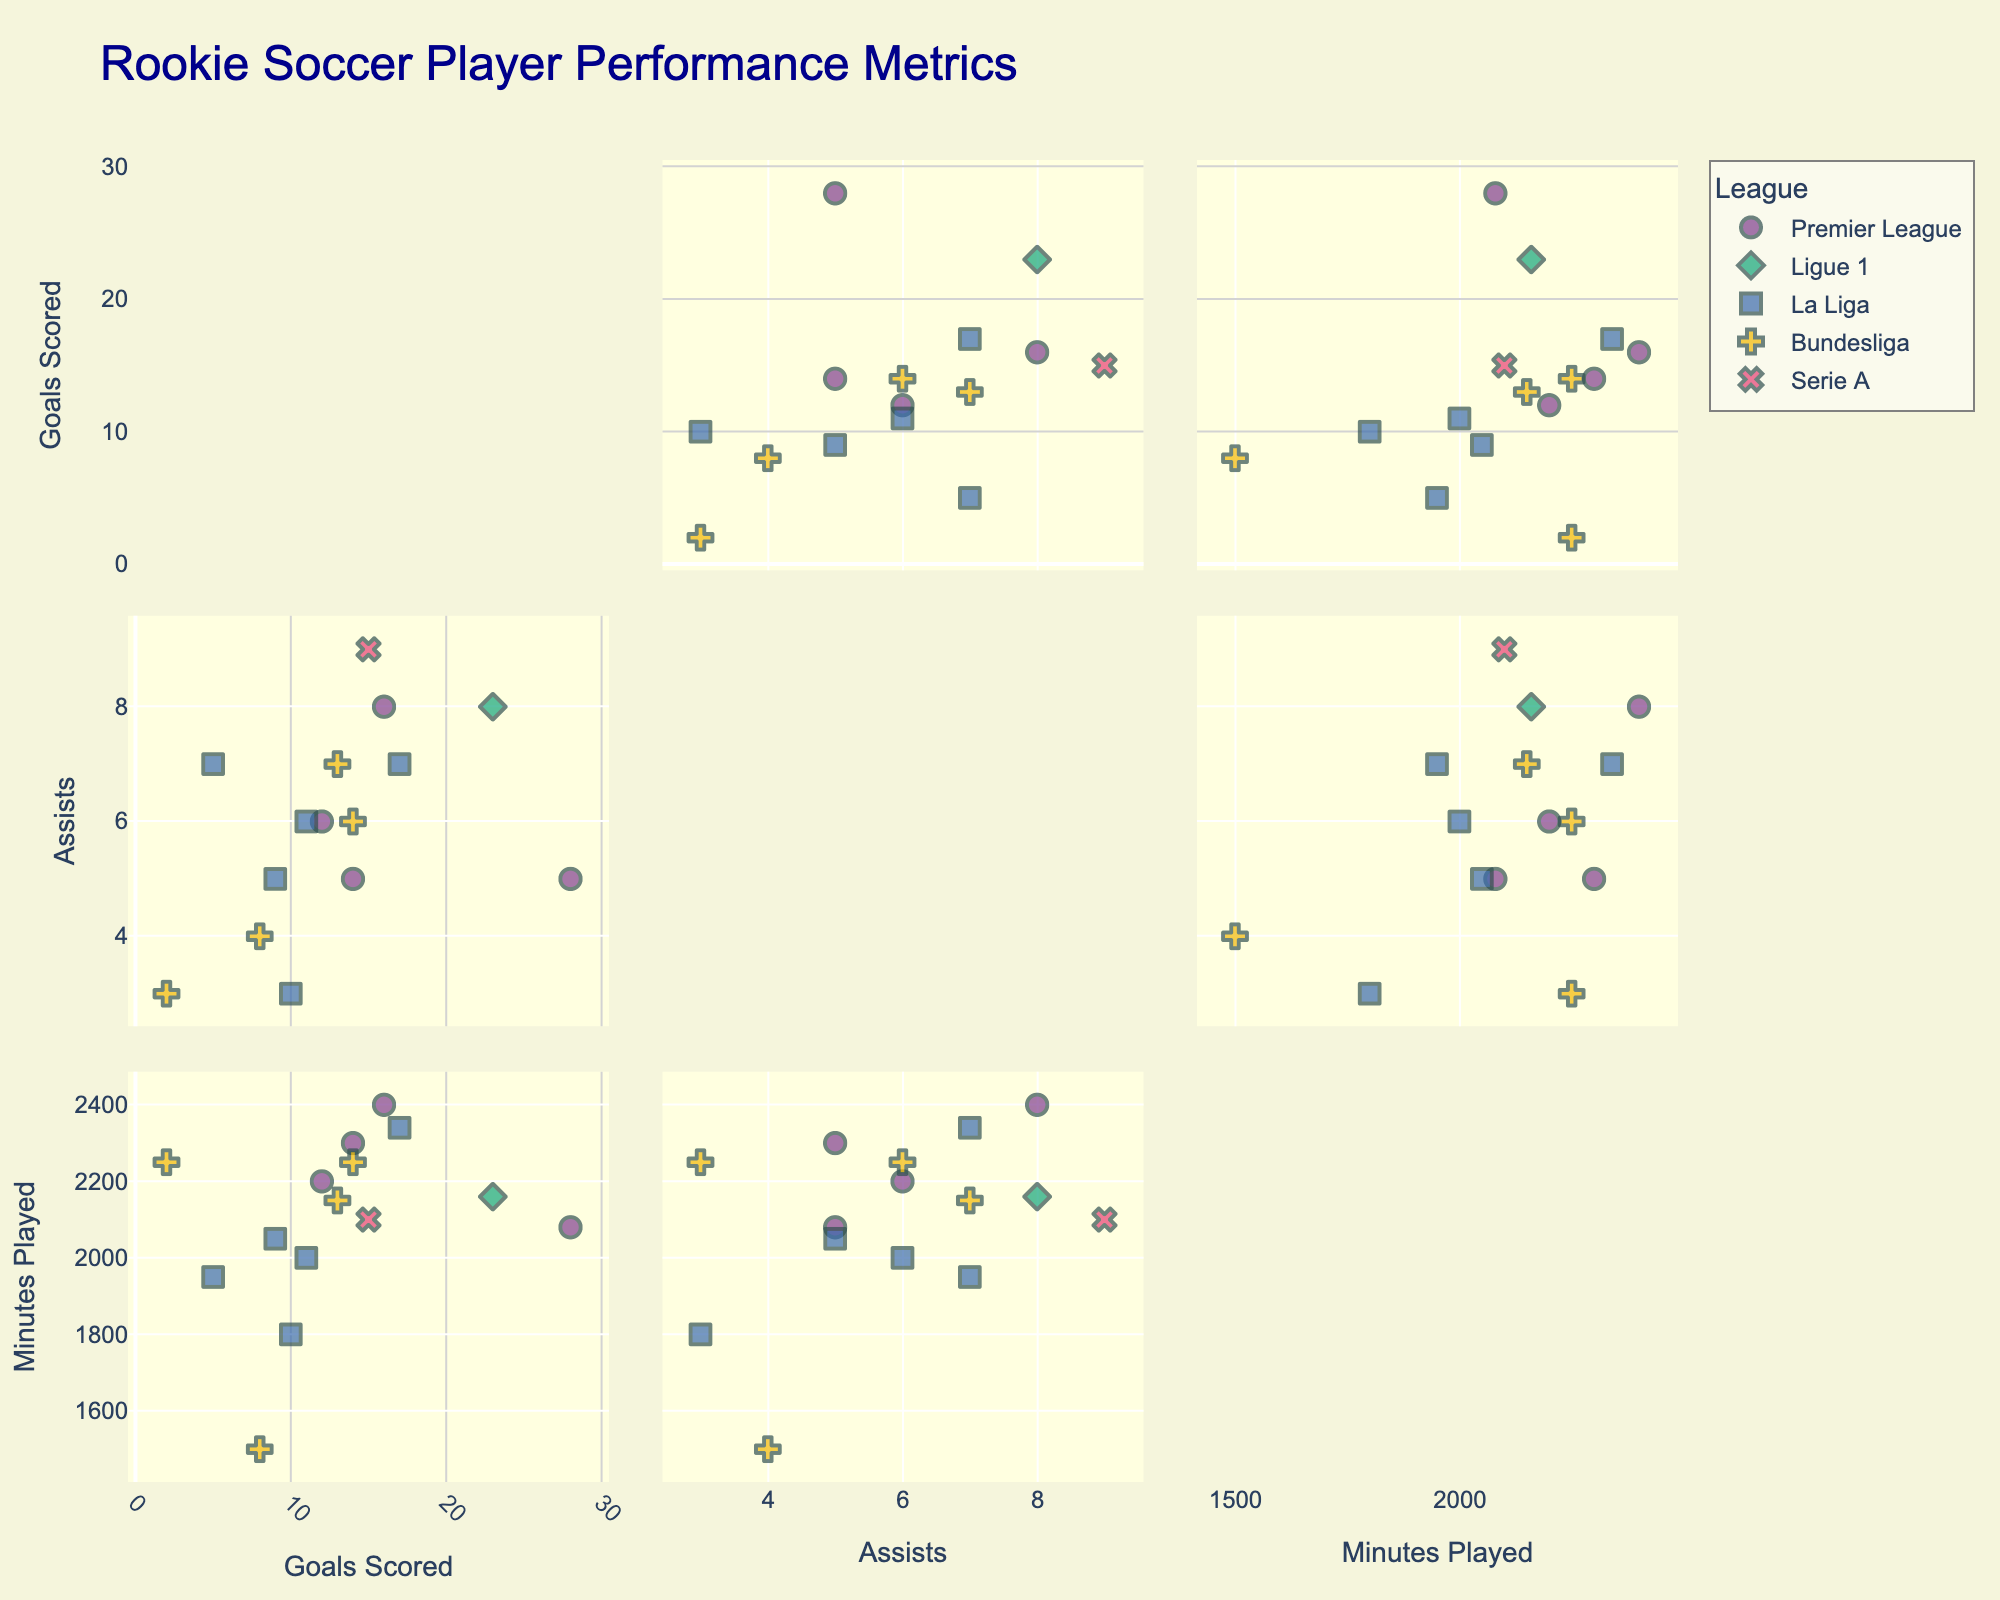What's the title of the figure? The title of the figure can be found at the top center of the image. It summarizes the content displayed in the figure.
Answer: Rookie Soccer Player Performance Metrics How many dimensions are visualized in the scatterplot matrix? The scatterplot matrix showcases different performance metrics through various plots along the horizontal and vertical axes. Count the number of unique metrics listed.
Answer: 3 Which player scored the most goals? Identify the data point that is farthest to the right on the 'Goals' axis. Hover over this point to see the player's name.
Answer: Erling Haaland Which player has the highest number of assists in the Premier League? Filter the data points by the 'Premier League' symbol. Then look for the maximum value on the 'Assists' axis among these points and hover over it to find the player's name.
Answer: Bukayo Saka What is the total number of assists by players in La Liga? Identify all data points in La Liga using their unique symbol. Sum up the values on the 'Assists' axis for these points. Considering data: Vinicius Jr (7), Ansu Fati (3), Eduardo Camavinga (7), Pedri (5), Rodrygo (6), the total is 7 + 3 + 7 + 5 + 6.
Answer: 28 Which league appears to have the most varied performance in terms of 'Goals'? Look at the spread of data points along the 'Goals' axis for each league. The league with the widest horizontal spread of points has the most variation.
Answer: Premier League Is there a positive correlation between 'Minutes Played' and 'Goals Scored'? Observe the data points in the scatterplot section involving 'Goals' and 'Minutes Played'. A positive correlation would show that as 'Minutes Played' increases, 'Goals Scored' also increases. Determine if the general trend follows this pattern.
Answer: Yes Which player plays in Bundesliga and has played the most minutes? Filter the data points by the 'Bundesliga' symbol. Then identify the data point furthest to the right on the 'Minutes' axis and hover over it to find the player's name.
Answer: Jude Bellingham What is the average number of assists among all players? Sum the 'Assists' for all players and divide by the number of players (15 players). Total assists are 5 + 8 + 7 + 6 + 9 + 4 + 3 + 6 + 7 + 8 + 5 + 7 + 6 + 5 + 3 = 89. Then, 89 / 15 = 5.93.
Answer: 5.93 How does the goal scoring performance of Vinicius Jr compare with Kylian Mbappe? Locate the data points for Vinicius Jr and Kylian Mbappe by hovering over them. Compare their positions on the 'Goals' axis to determine who scored more.
Answer: Kylian Mbappe scored more 